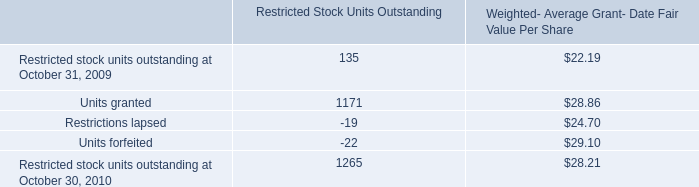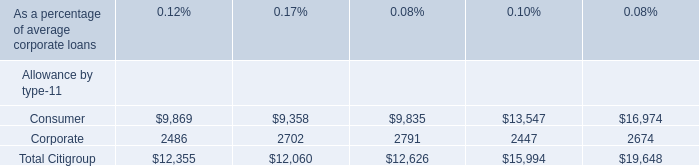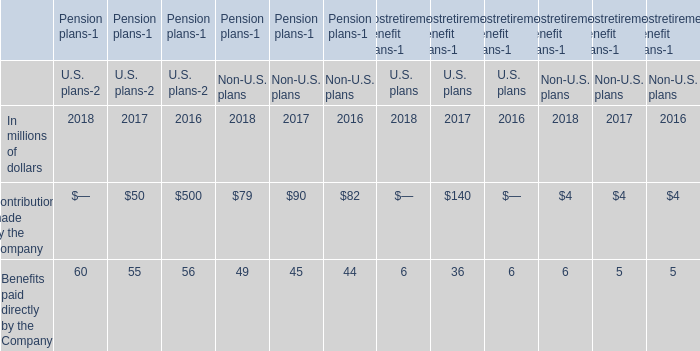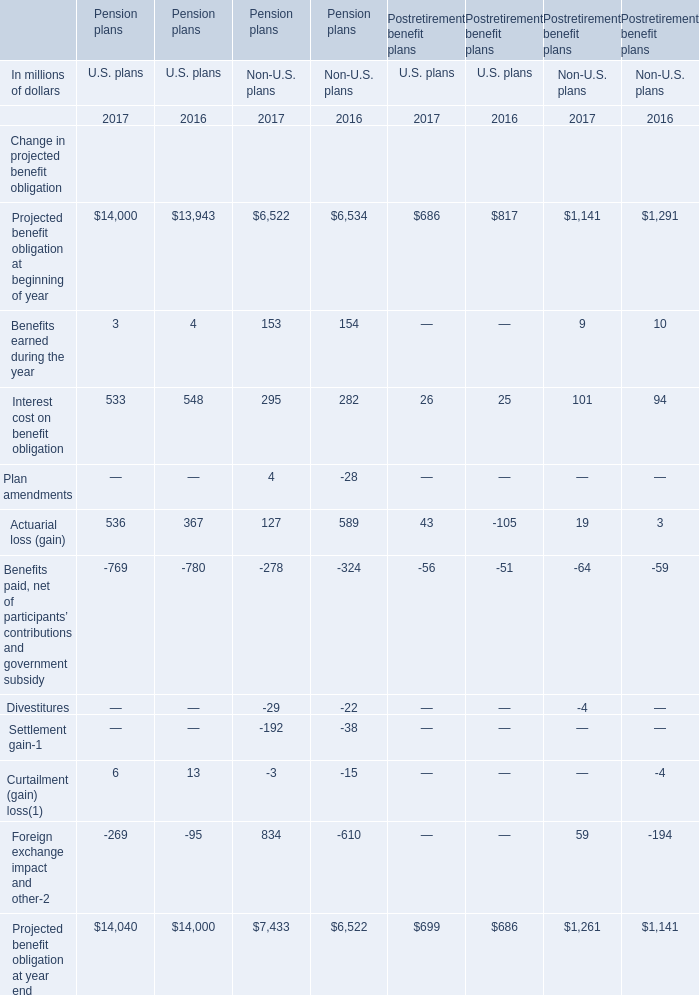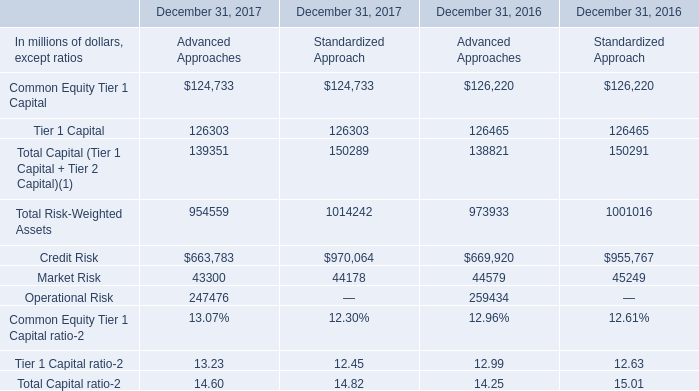Does Benefits paid directly by the Company keeps increasing each year between 2016 and 2018 for U.S. plans? 
Answer: no. 